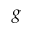<formula> <loc_0><loc_0><loc_500><loc_500>g</formula> 